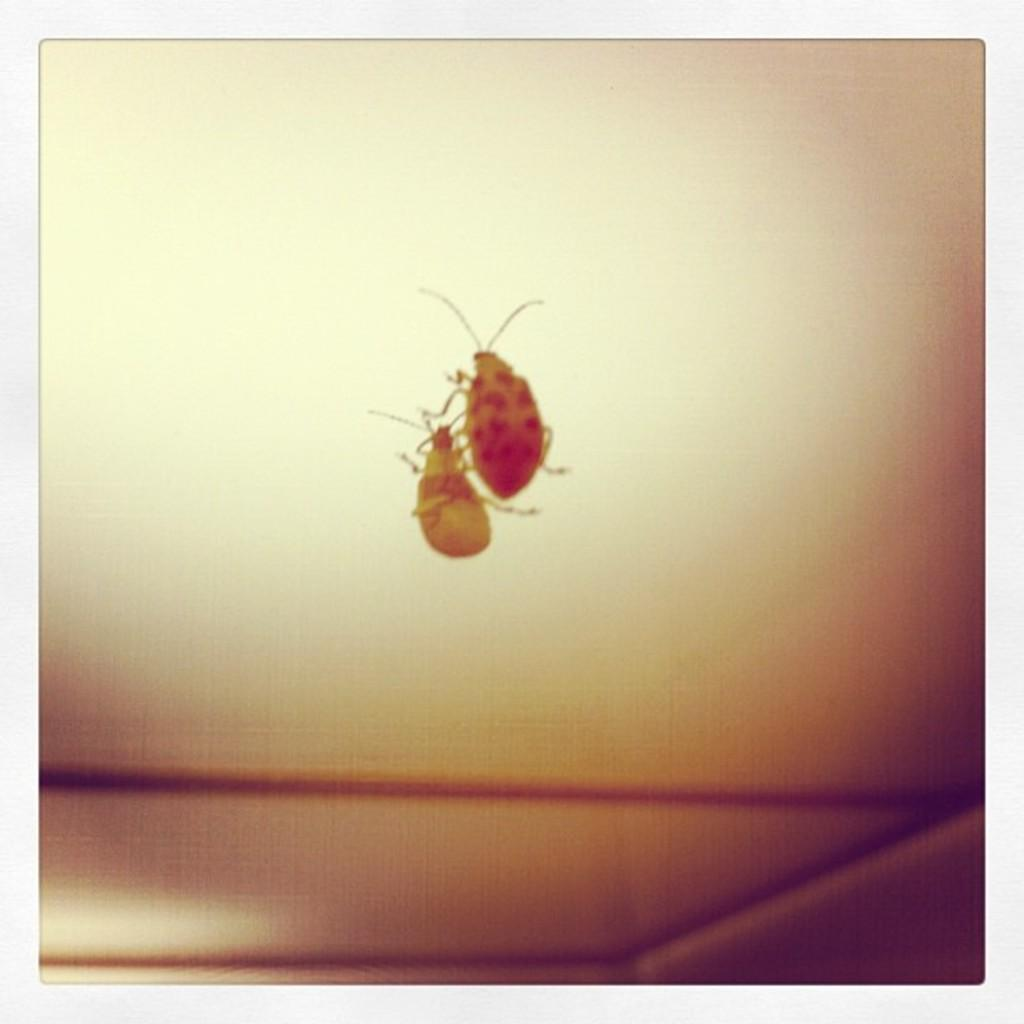What is on the mirror in the image? There is an insect on the mirror in the image. What can be seen in the reflection on the mirror? The reflection of the insect is visible on the mirror. What is the size of the discussion happening in the image? There is no discussion present in the image, so it is not possible to determine its size. 